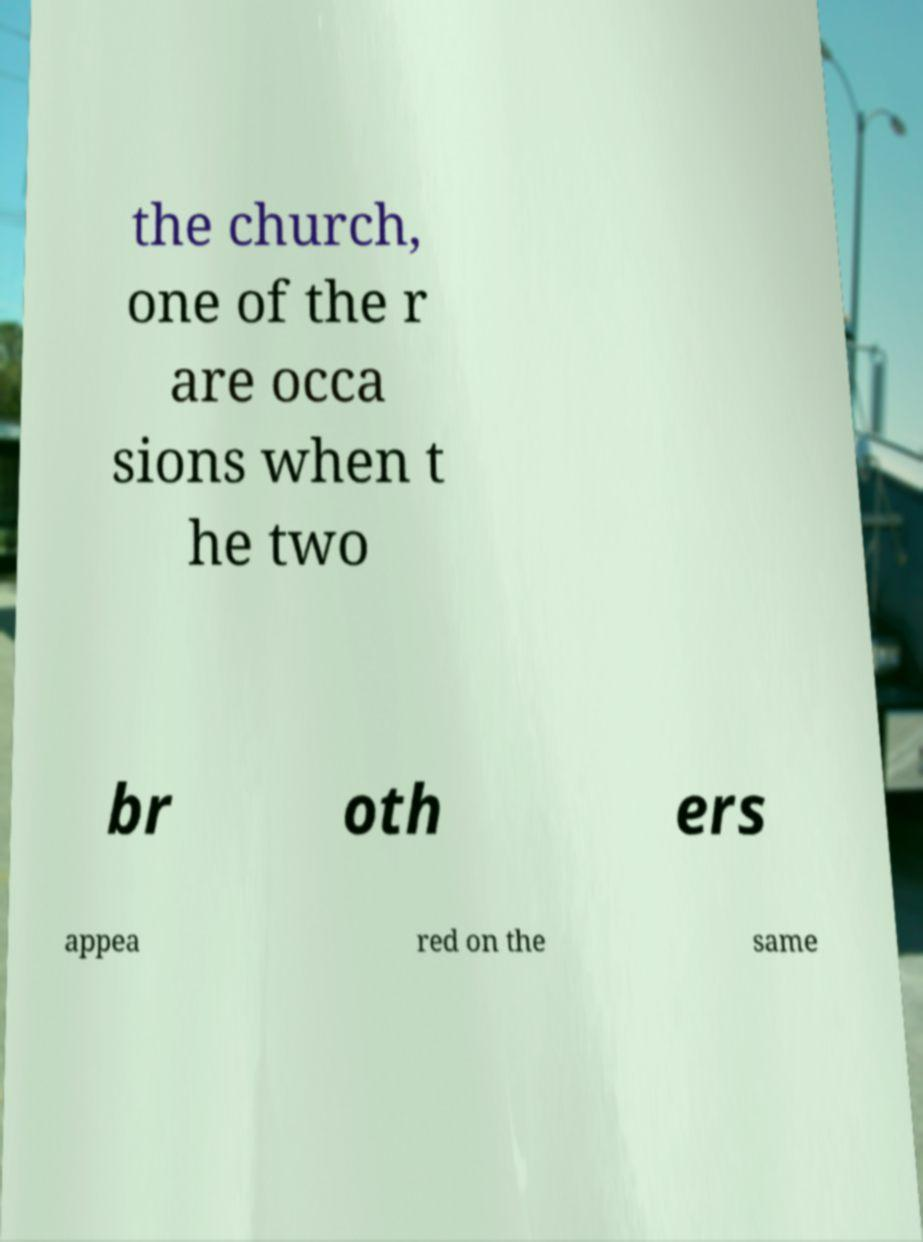Please read and relay the text visible in this image. What does it say? the church, one of the r are occa sions when t he two br oth ers appea red on the same 